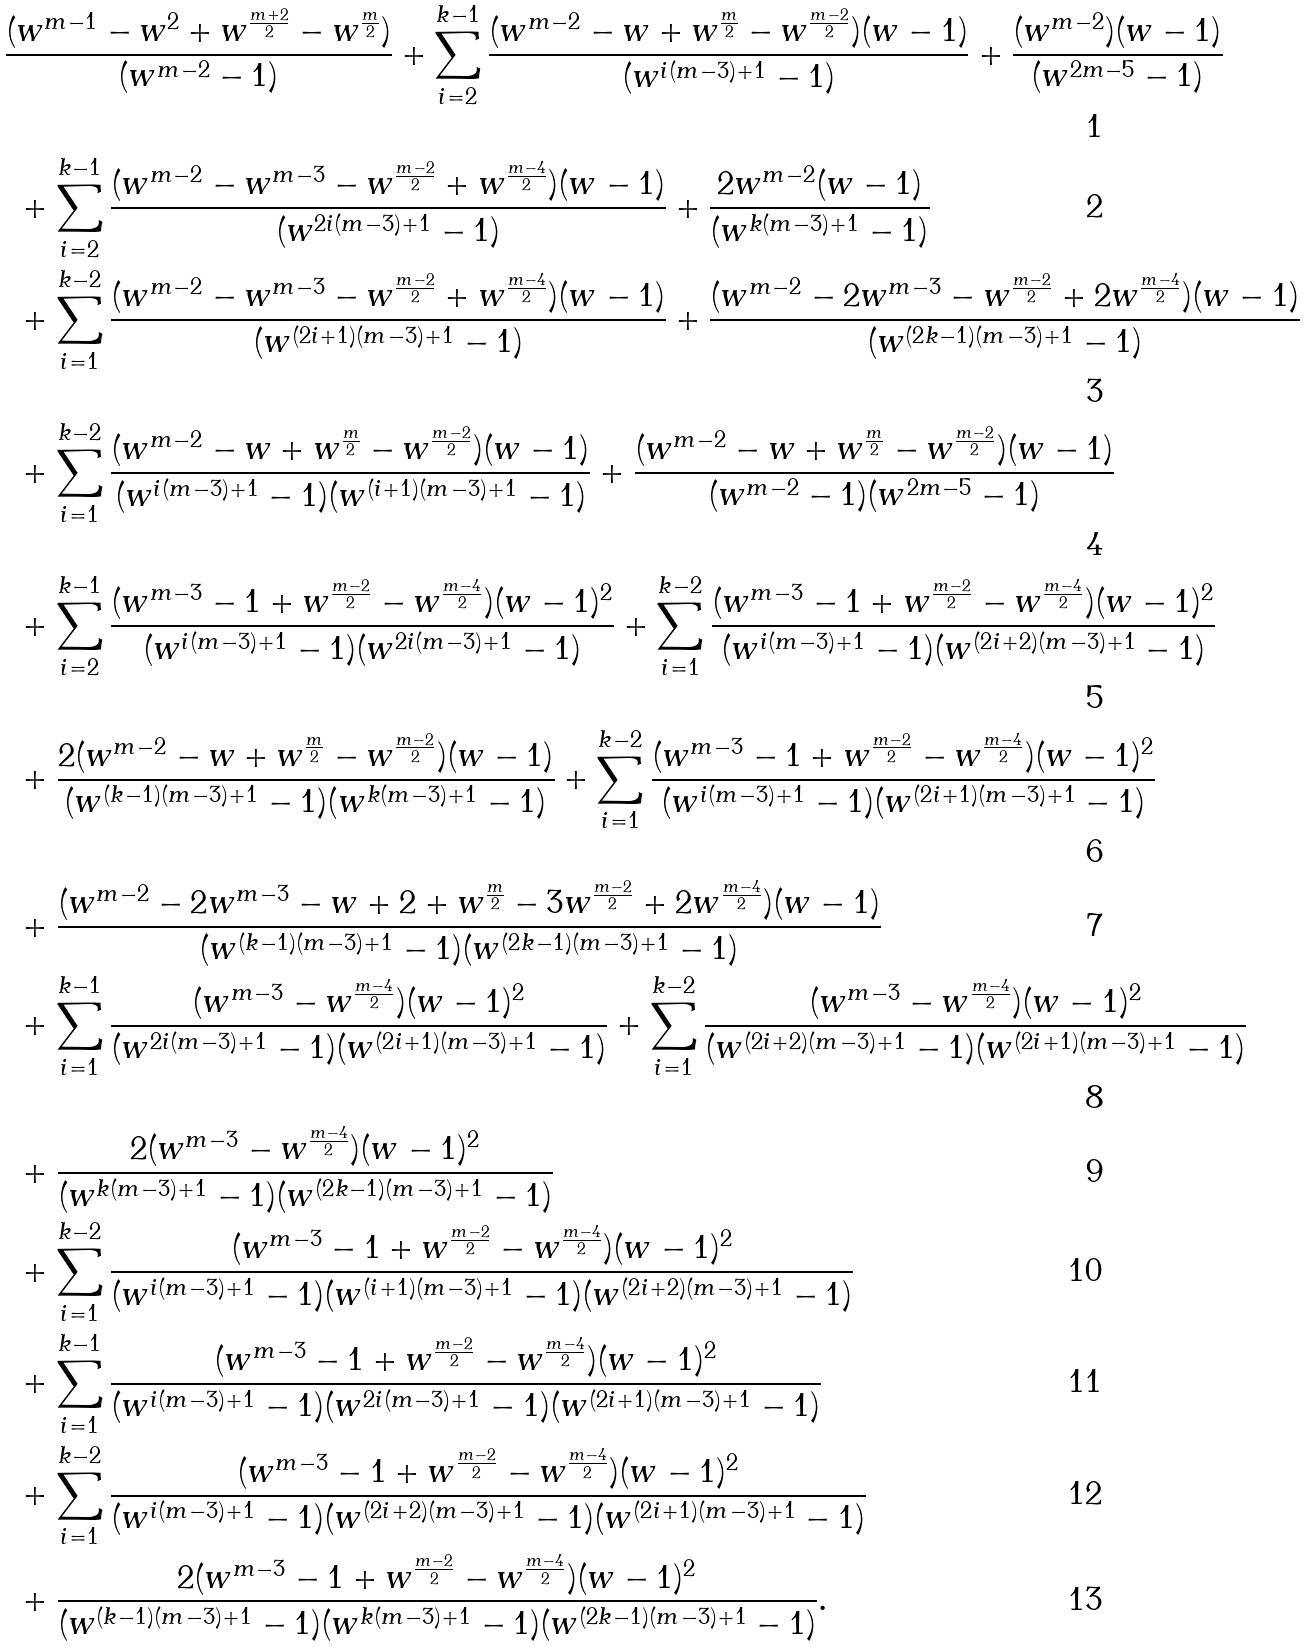Convert formula to latex. <formula><loc_0><loc_0><loc_500><loc_500>& \frac { ( w ^ { m - 1 } - w ^ { 2 } + w ^ { \frac { m + 2 } { 2 } } - w ^ { \frac { m } { 2 } } ) } { ( w ^ { m - 2 } - 1 ) } + \sum _ { i = 2 } ^ { k - 1 } \frac { ( w ^ { m - 2 } - w + w ^ { \frac { m } { 2 } } - w ^ { \frac { m - 2 } { 2 } } ) ( w - 1 ) } { ( w ^ { i ( m - 3 ) + 1 } - 1 ) } + \frac { ( w ^ { m - 2 } ) ( w - 1 ) } { ( w ^ { 2 m - 5 } - 1 ) } \\ & \ + \sum _ { i = 2 } ^ { k - 1 } \frac { ( w ^ { m - 2 } - w ^ { m - 3 } - w ^ { \frac { m - 2 } { 2 } } + w ^ { \frac { m - 4 } { 2 } } ) ( w - 1 ) } { ( w ^ { 2 i ( m - 3 ) + 1 } - 1 ) } + \frac { 2 w ^ { m - 2 } ( w - 1 ) } { ( w ^ { k ( m - 3 ) + 1 } - 1 ) } \\ & \ + \sum _ { i = 1 } ^ { k - 2 } \frac { ( w ^ { m - 2 } - w ^ { m - 3 } - w ^ { \frac { m - 2 } { 2 } } + w ^ { \frac { m - 4 } { 2 } } ) ( w - 1 ) } { ( w ^ { ( 2 i + 1 ) ( m - 3 ) + 1 } - 1 ) } + \frac { ( w ^ { m - 2 } - 2 w ^ { m - 3 } - w ^ { \frac { m - 2 } { 2 } } + 2 w ^ { \frac { m - 4 } { 2 } } ) ( w - 1 ) } { ( w ^ { ( 2 k - 1 ) ( m - 3 ) + 1 } - 1 ) } \\ & \ + \sum _ { i = 1 } ^ { k - 2 } \frac { ( w ^ { m - 2 } - w + w ^ { \frac { m } { 2 } } - w ^ { \frac { m - 2 } { 2 } } ) ( w - 1 ) } { ( w ^ { i ( m - 3 ) + 1 } - 1 ) ( w ^ { ( i + 1 ) ( m - 3 ) + 1 } - 1 ) } + \frac { ( w ^ { m - 2 } - w + w ^ { \frac { m } { 2 } } - w ^ { \frac { m - 2 } { 2 } } ) ( w - 1 ) } { ( w ^ { m - 2 } - 1 ) ( w ^ { 2 m - 5 } - 1 ) } \\ & \ + \sum _ { i = 2 } ^ { k - 1 } \frac { ( w ^ { m - 3 } - 1 + w ^ { \frac { m - 2 } { 2 } } - w ^ { \frac { m - 4 } { 2 } } ) ( w - 1 ) ^ { 2 } } { ( w ^ { i ( m - 3 ) + 1 } - 1 ) ( w ^ { 2 i ( m - 3 ) + 1 } - 1 ) } + \sum _ { i = 1 } ^ { k - 2 } \frac { ( w ^ { m - 3 } - 1 + w ^ { \frac { m - 2 } { 2 } } - w ^ { \frac { m - 4 } { 2 } } ) ( w - 1 ) ^ { 2 } } { ( w ^ { i ( m - 3 ) + 1 } - 1 ) ( w ^ { ( 2 i + 2 ) ( m - 3 ) + 1 } - 1 ) } \\ & \ + \frac { 2 ( w ^ { m - 2 } - w + w ^ { \frac { m } { 2 } } - w ^ { \frac { m - 2 } { 2 } } ) ( w - 1 ) } { ( w ^ { ( k - 1 ) ( m - 3 ) + 1 } - 1 ) ( w ^ { k ( m - 3 ) + 1 } - 1 ) } + \sum _ { i = 1 } ^ { k - 2 } \frac { ( w ^ { m - 3 } - 1 + w ^ { \frac { m - 2 } { 2 } } - w ^ { \frac { m - 4 } { 2 } } ) ( w - 1 ) ^ { 2 } } { ( w ^ { i ( m - 3 ) + 1 } - 1 ) ( w ^ { ( 2 i + 1 ) ( m - 3 ) + 1 } - 1 ) } \\ & \ + \frac { ( w ^ { m - 2 } - 2 w ^ { m - 3 } - w + 2 + w ^ { \frac { m } { 2 } } - 3 w ^ { \frac { m - 2 } { 2 } } + 2 w ^ { \frac { m - 4 } { 2 } } ) ( w - 1 ) } { ( w ^ { ( k - 1 ) ( m - 3 ) + 1 } - 1 ) ( w ^ { ( 2 k - 1 ) ( m - 3 ) + 1 } - 1 ) } \\ & \ + \sum _ { i = 1 } ^ { k - 1 } \frac { ( w ^ { m - 3 } - w ^ { \frac { m - 4 } { 2 } } ) ( w - 1 ) ^ { 2 } } { ( w ^ { 2 i ( m - 3 ) + 1 } - 1 ) ( w ^ { ( 2 i + 1 ) ( m - 3 ) + 1 } - 1 ) } + \sum _ { i = 1 } ^ { k - 2 } \frac { ( w ^ { m - 3 } - w ^ { \frac { m - 4 } { 2 } } ) ( w - 1 ) ^ { 2 } } { ( w ^ { ( 2 i + 2 ) ( m - 3 ) + 1 } - 1 ) ( w ^ { ( 2 i + 1 ) ( m - 3 ) + 1 } - 1 ) } \\ & \ + \frac { 2 ( w ^ { m - 3 } - w ^ { \frac { m - 4 } { 2 } } ) ( w - 1 ) ^ { 2 } } { ( w ^ { k ( m - 3 ) + 1 } - 1 ) ( w ^ { ( 2 k - 1 ) ( m - 3 ) + 1 } - 1 ) } \\ & \ + \sum _ { i = 1 } ^ { k - 2 } \frac { ( w ^ { m - 3 } - 1 + w ^ { \frac { m - 2 } { 2 } } - w ^ { \frac { m - 4 } { 2 } } ) ( w - 1 ) ^ { 2 } } { ( w ^ { i ( m - 3 ) + 1 } - 1 ) ( w ^ { ( i + 1 ) ( m - 3 ) + 1 } - 1 ) ( w ^ { ( 2 i + 2 ) ( m - 3 ) + 1 } - 1 ) } \\ & \ + \sum _ { i = 1 } ^ { k - 1 } \frac { ( w ^ { m - 3 } - 1 + w ^ { \frac { m - 2 } { 2 } } - w ^ { \frac { m - 4 } { 2 } } ) ( w - 1 ) ^ { 2 } } { ( w ^ { i ( m - 3 ) + 1 } - 1 ) ( w ^ { 2 i ( m - 3 ) + 1 } - 1 ) ( w ^ { ( 2 i + 1 ) ( m - 3 ) + 1 } - 1 ) } \\ & \ + \sum _ { i = 1 } ^ { k - 2 } \frac { ( w ^ { m - 3 } - 1 + w ^ { \frac { m - 2 } { 2 } } - w ^ { \frac { m - 4 } { 2 } } ) ( w - 1 ) ^ { 2 } } { ( w ^ { i ( m - 3 ) + 1 } - 1 ) ( w ^ { ( 2 i + 2 ) ( m - 3 ) + 1 } - 1 ) ( w ^ { ( 2 i + 1 ) ( m - 3 ) + 1 } - 1 ) } \\ & \ + \frac { 2 ( w ^ { m - 3 } - 1 + w ^ { \frac { m - 2 } { 2 } } - w ^ { \frac { m - 4 } { 2 } } ) ( w - 1 ) ^ { 2 } } { ( w ^ { ( k - 1 ) ( m - 3 ) + 1 } - 1 ) ( w ^ { k ( m - 3 ) + 1 } - 1 ) ( w ^ { ( 2 k - 1 ) ( m - 3 ) + 1 } - 1 ) } .</formula> 